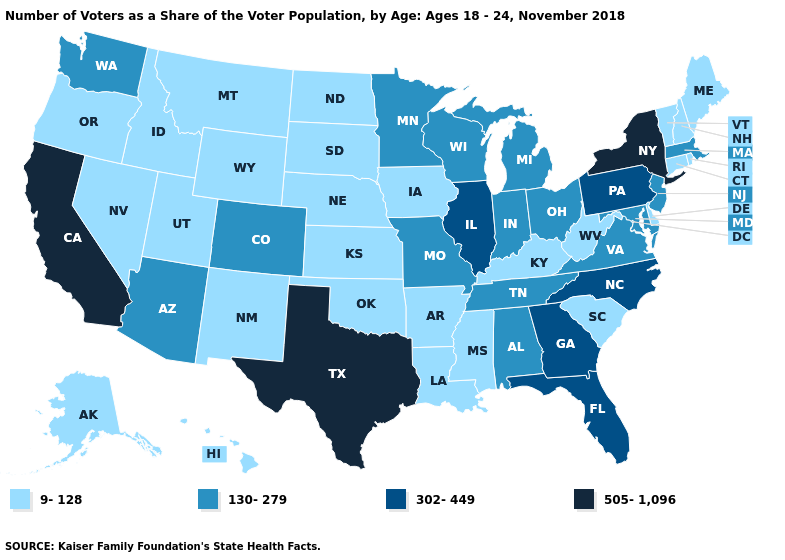Name the states that have a value in the range 505-1,096?
Give a very brief answer. California, New York, Texas. What is the lowest value in the Northeast?
Be succinct. 9-128. What is the lowest value in states that border Mississippi?
Be succinct. 9-128. Does Hawaii have a lower value than Pennsylvania?
Give a very brief answer. Yes. What is the highest value in the USA?
Answer briefly. 505-1,096. Name the states that have a value in the range 505-1,096?
Give a very brief answer. California, New York, Texas. Which states have the highest value in the USA?
Be succinct. California, New York, Texas. Does Vermont have the lowest value in the Northeast?
Be succinct. Yes. What is the value of Louisiana?
Answer briefly. 9-128. What is the value of Kentucky?
Keep it brief. 9-128. What is the highest value in states that border Idaho?
Concise answer only. 130-279. What is the value of Oklahoma?
Short answer required. 9-128. Among the states that border Indiana , does Illinois have the highest value?
Short answer required. Yes. What is the highest value in states that border South Dakota?
Quick response, please. 130-279. 